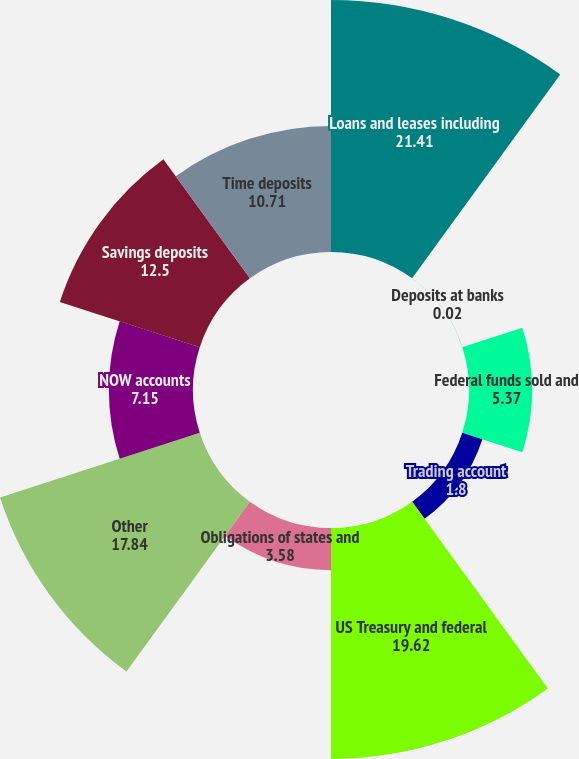Convert chart. <chart><loc_0><loc_0><loc_500><loc_500><pie_chart><fcel>Loans and leases including<fcel>Deposits at banks<fcel>Federal funds sold and<fcel>Trading account<fcel>US Treasury and federal<fcel>Obligations of states and<fcel>Other<fcel>NOW accounts<fcel>Savings deposits<fcel>Time deposits<nl><fcel>21.41%<fcel>0.02%<fcel>5.37%<fcel>1.8%<fcel>19.62%<fcel>3.58%<fcel>17.84%<fcel>7.15%<fcel>12.5%<fcel>10.71%<nl></chart> 